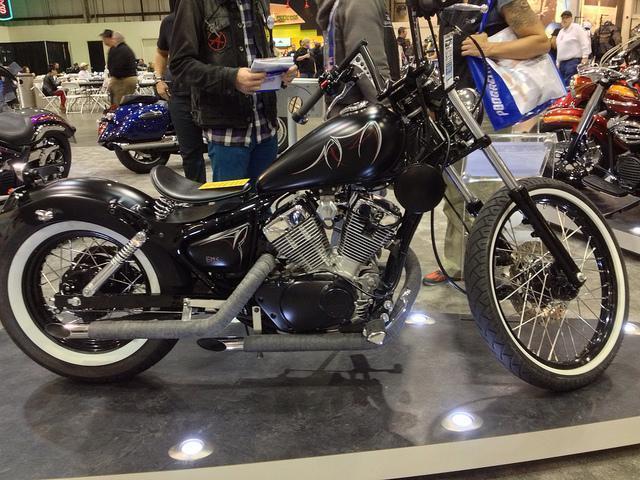What would you call the metal poles connecting to the front wheel?
Choose the right answer and clarify with the format: 'Answer: answer
Rationale: rationale.'
Options: Spoon, fork, knife, fender. Answer: fork.
Rationale: This looks like tines on this utensil 